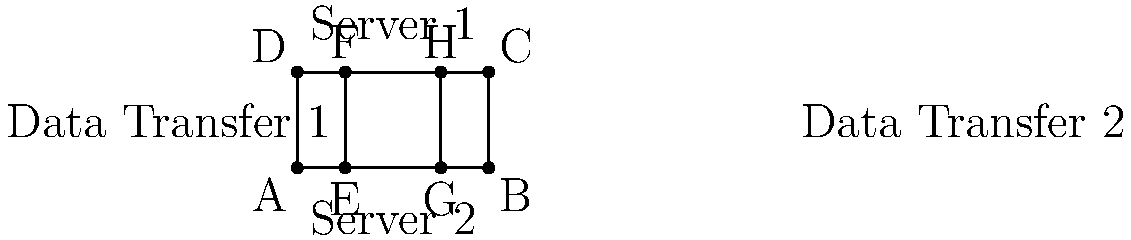In the diagram above, two parallel data transfer lines (EF and GH) connect mirrored servers. If the distance between the servers is 50 units and EG = 50 units, what is the ratio of the area of rectangle EFGH to the total area of rectangle ABCD? Let's approach this step-by-step:

1) First, we need to identify the dimensions of rectangle ABCD:
   - Width (AB) = 100 units (given that EG = 50 and it's half of AB)
   - Height (AD) = 50 units (given as the distance between servers)

2) The area of rectangle ABCD is:
   $$A_{ABCD} = 100 \times 50 = 5000$$ square units

3) Now, let's look at rectangle EFGH:
   - Width (EG) = 50 units (given)
   - Height (EF) = 50 units (same as AD, as they are parallel)

4) The area of rectangle EFGH is:
   $$A_{EFGH} = 50 \times 50 = 2500$$ square units

5) To find the ratio, we divide the area of EFGH by the area of ABCD:
   $$\text{Ratio} = \frac{A_{EFGH}}{A_{ABCD}} = \frac{2500}{5000} = \frac{1}{2} = 0.5$$

6) This can be simplified to 1:2 or expressed as 50%.
Answer: 1:2 or 0.5 or 50% 